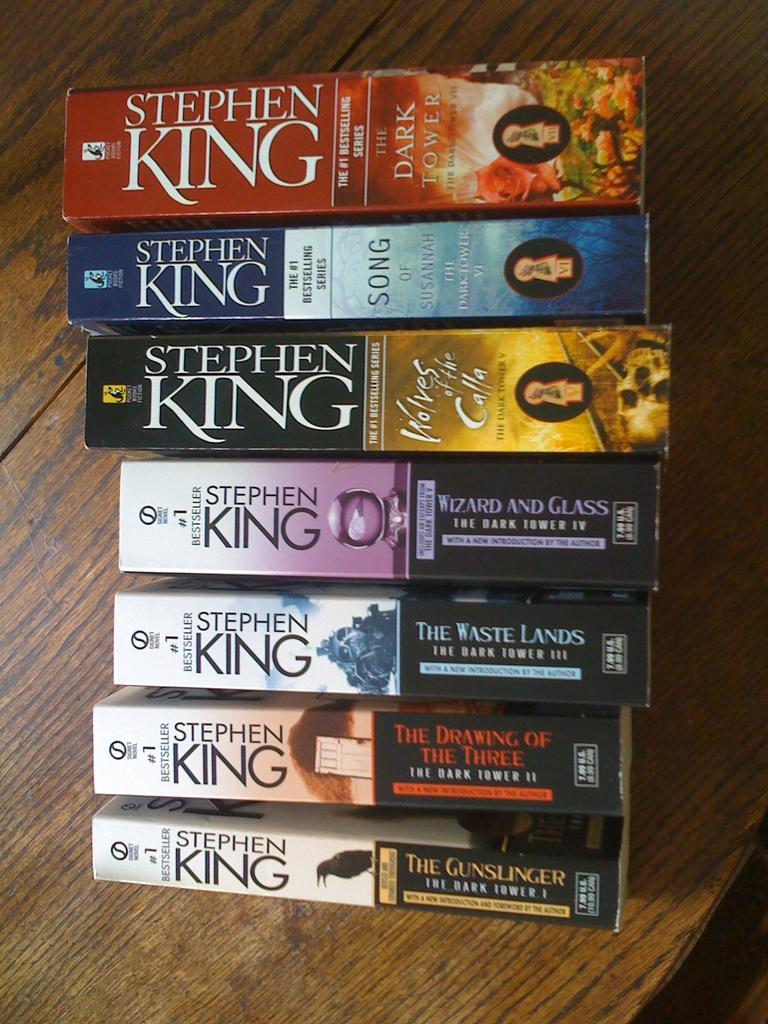Provide a one-sentence caption for the provided image. Boxes of Video Home System tapes based on Stephen King stories. 